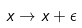Convert formula to latex. <formula><loc_0><loc_0><loc_500><loc_500>x \to x + \epsilon</formula> 